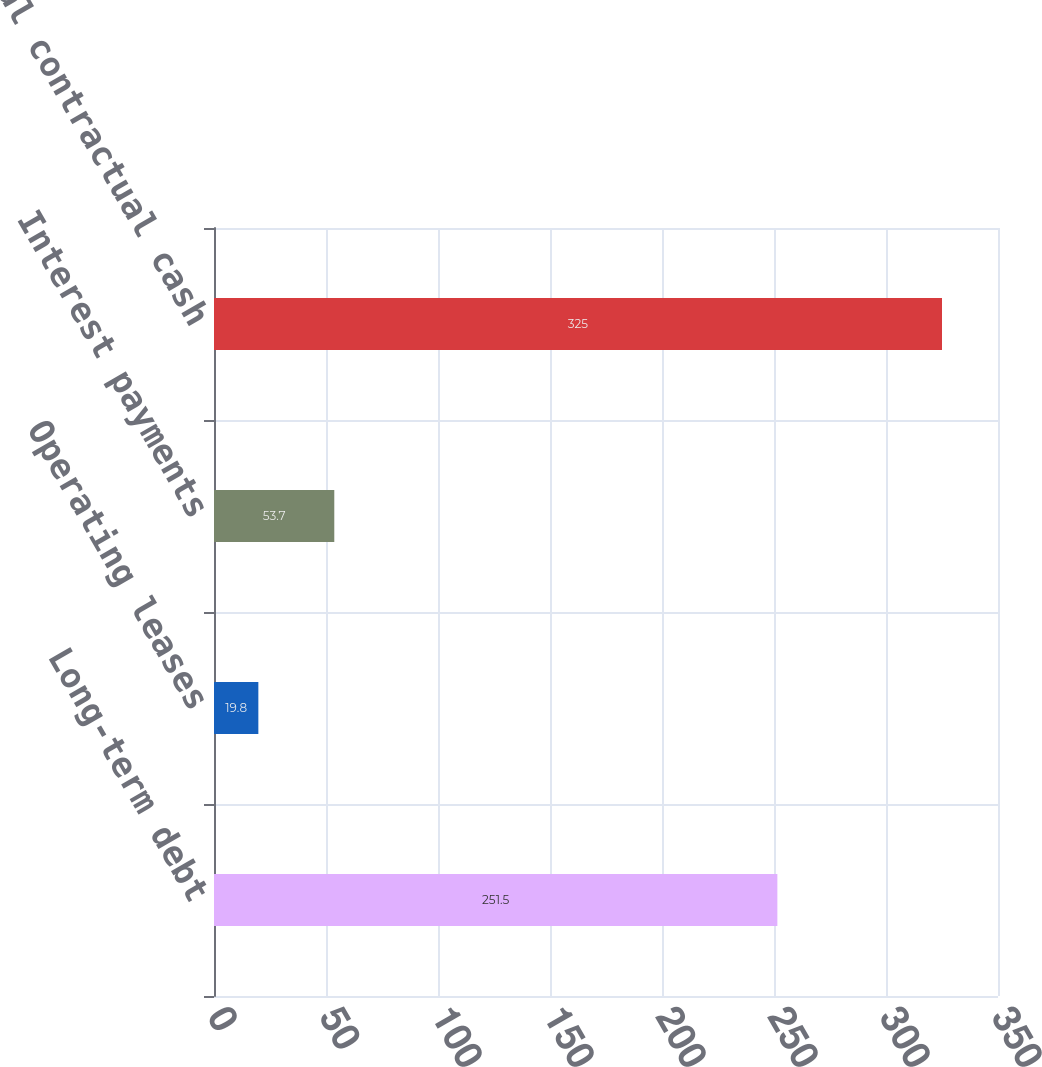Convert chart to OTSL. <chart><loc_0><loc_0><loc_500><loc_500><bar_chart><fcel>Long-term debt<fcel>Operating leases<fcel>Interest payments<fcel>Total contractual cash<nl><fcel>251.5<fcel>19.8<fcel>53.7<fcel>325<nl></chart> 